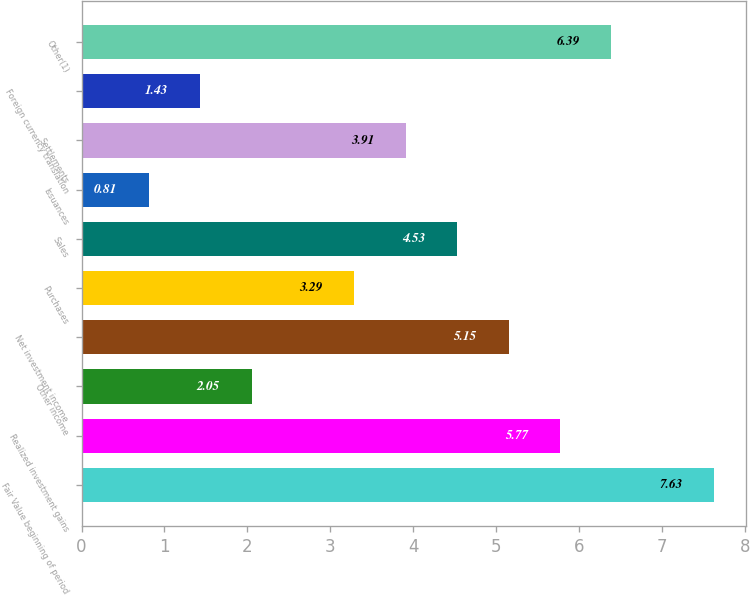Convert chart. <chart><loc_0><loc_0><loc_500><loc_500><bar_chart><fcel>Fair Value beginning of period<fcel>Realized investment gains<fcel>Other income<fcel>Net investment income<fcel>Purchases<fcel>Sales<fcel>Issuances<fcel>Settlements<fcel>Foreign currency translation<fcel>Other(1)<nl><fcel>7.63<fcel>5.77<fcel>2.05<fcel>5.15<fcel>3.29<fcel>4.53<fcel>0.81<fcel>3.91<fcel>1.43<fcel>6.39<nl></chart> 